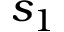<formula> <loc_0><loc_0><loc_500><loc_500>s _ { 1 }</formula> 